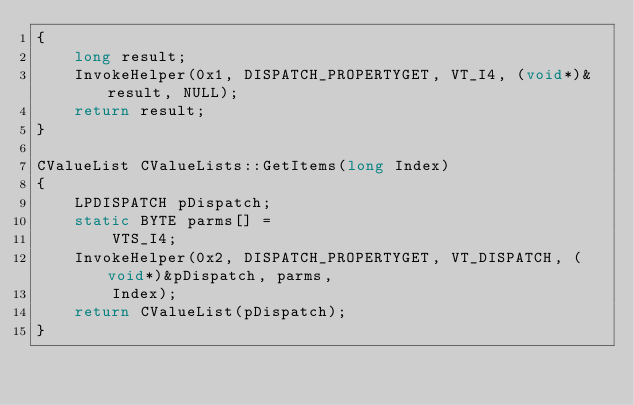<code> <loc_0><loc_0><loc_500><loc_500><_C++_>{
	long result;
	InvokeHelper(0x1, DISPATCH_PROPERTYGET, VT_I4, (void*)&result, NULL);
	return result;
}

CValueList CValueLists::GetItems(long Index)
{
	LPDISPATCH pDispatch;
	static BYTE parms[] =
		VTS_I4;
	InvokeHelper(0x2, DISPATCH_PROPERTYGET, VT_DISPATCH, (void*)&pDispatch, parms,
		Index);
	return CValueList(pDispatch);
}
</code> 